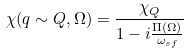<formula> <loc_0><loc_0><loc_500><loc_500>\chi ( q \sim Q , \Omega ) = \frac { \chi _ { Q } } { 1 - i \frac { \Pi ( \Omega ) } { \omega _ { s f } } }</formula> 